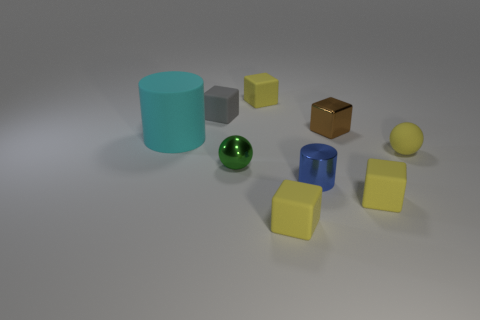Do the cylinder that is to the right of the big rubber cylinder and the tiny sphere that is behind the green metal sphere have the same material? While the response was simply 'no', a more detailed examination reveals that the cylinder to the right of the larger rubber cylinder appears to have a matte finish, indicating it may be made of a rubber or plastic with a non-reflective surface. The tiny sphere, although not distinctly visible, seems to have a slight reflective quality suggesting it could be metallic or glass. Therefore, based on the visible properties of the objects in question, they do not seem to have the same material. 